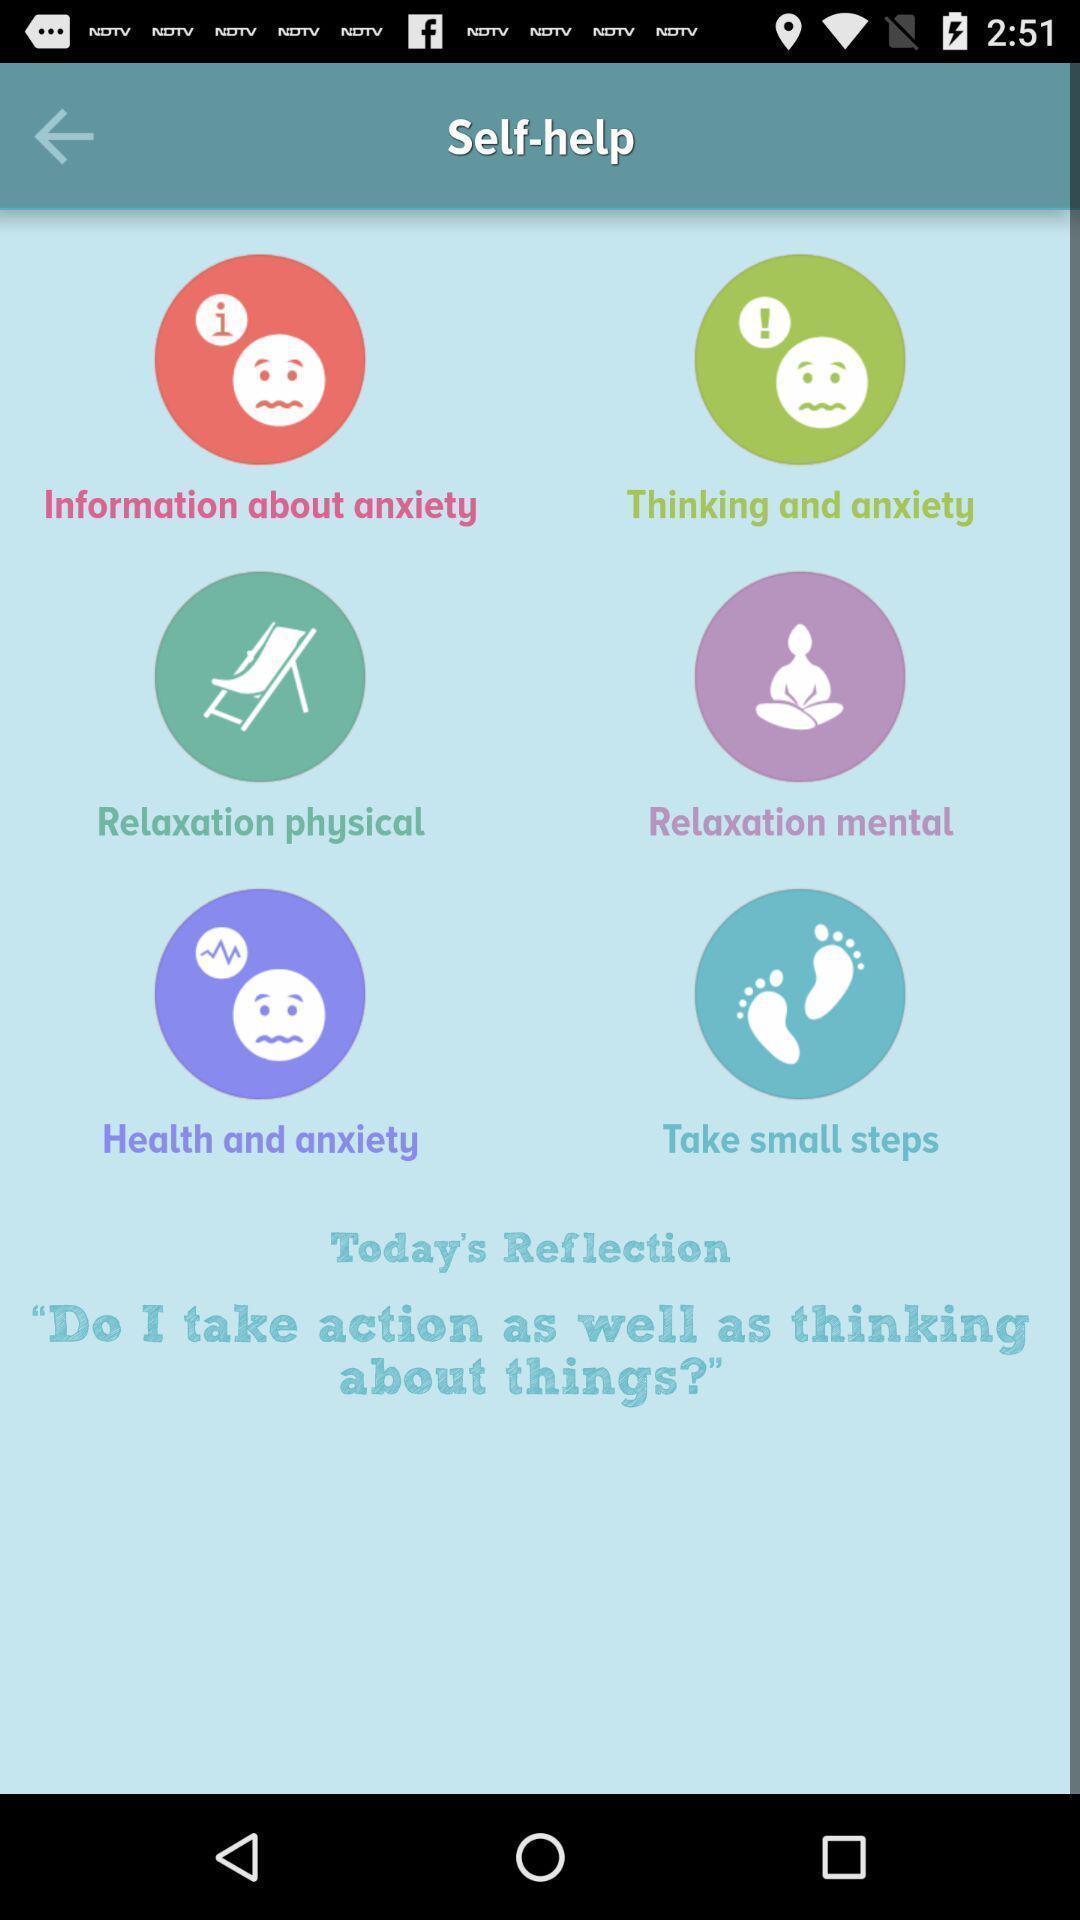What can you discern from this picture? Screen displaying the list of self help methods. 